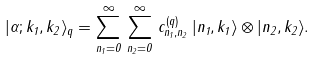<formula> <loc_0><loc_0><loc_500><loc_500>| \alpha ; k _ { 1 } , k _ { 2 } \rangle _ { q } = \sum _ { n _ { 1 } = 0 } ^ { \infty } \, \sum _ { n _ { 2 } = 0 } ^ { \infty } \, c _ { n _ { 1 } , n _ { 2 } } ^ { ( q ) } \, | n _ { 1 } , k _ { 1 } \rangle \otimes | n _ { 2 } , k _ { 2 } \rangle .</formula> 